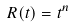<formula> <loc_0><loc_0><loc_500><loc_500>R ( t ) = t ^ { n }</formula> 